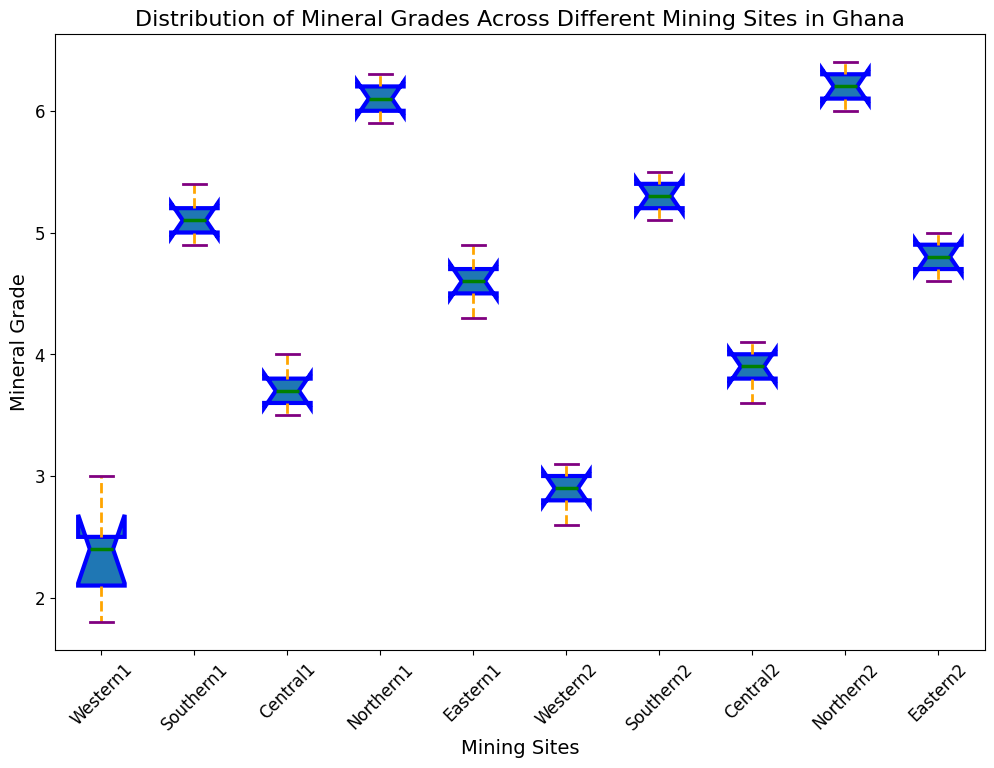What's the median mineral grade at Northern1? To find the median, locate the middle value in the sorted list of grades for Northern1. The sorted grades are 5.9, 6.0, 6.1, 6.2, 6.3. The median value is 6.1.
Answer: 6.1 Which site has the highest median mineral grade? Observe the median lines (typically marked in green) in the boxes for each mining site. Northern1 and Northern2 have the highest medians, well above that of other sites.
Answer: Northern1 and Northern2 Compare the interquartile range (IQR) of Western1 and Northern2. Which one is larger? The IQR is the difference between the upper quartile (75th percentile) and lower quartile (25th percentile). Visually, compare the lengths of the boxes of Western1 and Northern2. Western1's box is narrower compared to Northern2's, indicating a smaller IQR for Western1.
Answer: Northern2 What is the range of mineral grades for Central2? The range is the difference between the maximum and minimum values. For Central2, the minimum value is around 3.6 and the maximum value is around 4.1. The range is 4.1 - 3.6 = 0.5.
Answer: 0.5 Which site has the most variability in mineral grades? Variability can be judged by the length of the whiskers and the spread of outliers. Northern1 and Northern2 have longer whiskers, suggesting higher variability.
Answer: Northern1 and Northern2 How does the median mineral grade of Eastern1 compare to Southern2? Compare the green lines (medians) in the boxes for Eastern1 and Southern2. The median mineral grade of Southern2 is higher than that of Eastern1.
Answer: Southern2 is higher Does Western1 have any outliers? Outliers are typically shown as small circles outside the whiskers. Western1 does not have any such circles.
Answer: No What’s the approximate difference in the median mineral grades between Western2 and Central1? The median for Western2 is around 2.9 and for Central1 is around 3.7. The difference is approximately 3.7 - 2.9 = 0.8.
Answer: 0.8 Which site has the narrowest spread of mineral grades? The spread can be judged by the overall length of the whiskers. Central2 has very short whiskers indicating a narrow spread.
Answer: Central2 Compare the number of outliers for Southern1 and Eastern2. Outliers are marked by circles outside the whiskers. Southern1 has one or two outliers, while Eastern2 does not have any visible outliers.
Answer: Southern1 has more outliers 